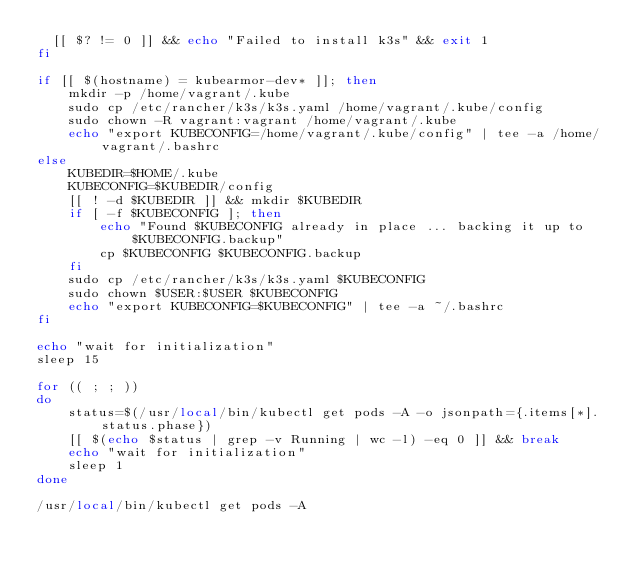<code> <loc_0><loc_0><loc_500><loc_500><_Bash_>  [[ $? != 0 ]] && echo "Failed to install k3s" && exit 1
fi

if [[ $(hostname) = kubearmor-dev* ]]; then
    mkdir -p /home/vagrant/.kube
    sudo cp /etc/rancher/k3s/k3s.yaml /home/vagrant/.kube/config
    sudo chown -R vagrant:vagrant /home/vagrant/.kube
    echo "export KUBECONFIG=/home/vagrant/.kube/config" | tee -a /home/vagrant/.bashrc
else
    KUBEDIR=$HOME/.kube
    KUBECONFIG=$KUBEDIR/config
    [[ ! -d $KUBEDIR ]] && mkdir $KUBEDIR
    if [ -f $KUBECONFIG ]; then
        echo "Found $KUBECONFIG already in place ... backing it up to $KUBECONFIG.backup"
        cp $KUBECONFIG $KUBECONFIG.backup
    fi
    sudo cp /etc/rancher/k3s/k3s.yaml $KUBECONFIG
    sudo chown $USER:$USER $KUBECONFIG
    echo "export KUBECONFIG=$KUBECONFIG" | tee -a ~/.bashrc
fi

echo "wait for initialization"
sleep 15

for (( ; ; ))
do
    status=$(/usr/local/bin/kubectl get pods -A -o jsonpath={.items[*].status.phase})
    [[ $(echo $status | grep -v Running | wc -l) -eq 0 ]] && break
    echo "wait for initialization"
    sleep 1
done

/usr/local/bin/kubectl get pods -A
</code> 